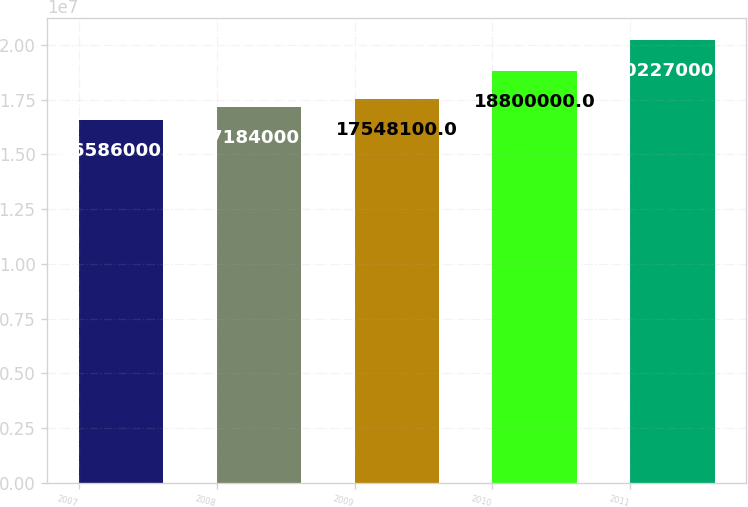Convert chart to OTSL. <chart><loc_0><loc_0><loc_500><loc_500><bar_chart><fcel>2007<fcel>2008<fcel>2009<fcel>2010<fcel>2011<nl><fcel>1.6586e+07<fcel>1.7184e+07<fcel>1.75481e+07<fcel>1.88e+07<fcel>2.0227e+07<nl></chart> 